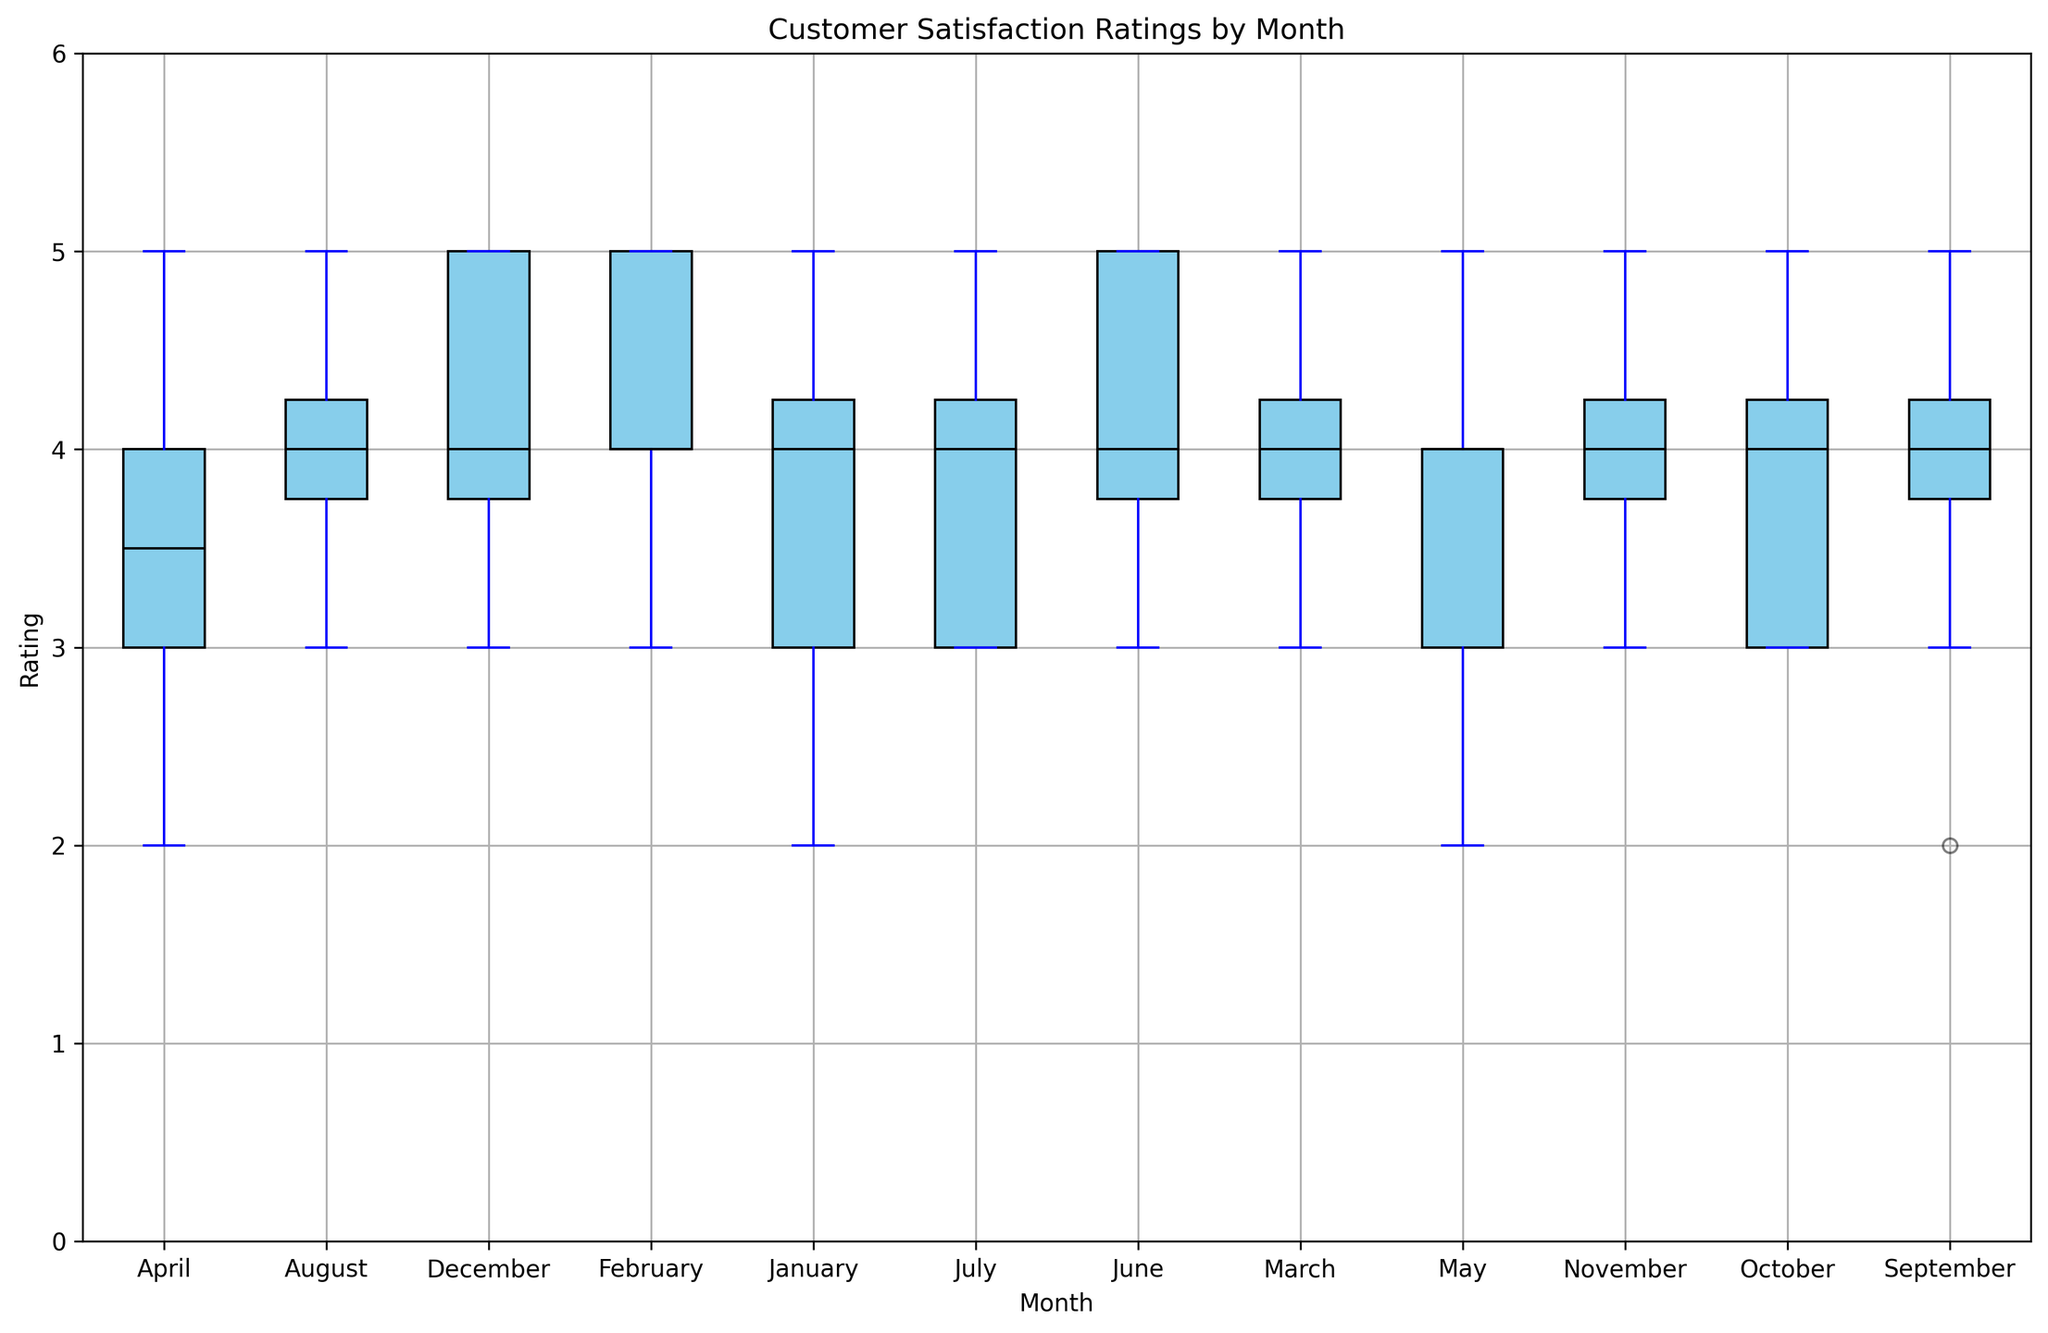Which month has the highest median customer satisfaction rating? Observe the median line in each box plot and identify the highest one. February, July, and December each have a median rating of 4.5, which is the highest observed.
Answer: February, July, and December Which month exhibits the largest range in customer satisfaction ratings? Look at the length of the whiskers (vertical lines) for each month to determine the range, which is the distance between the minimum and maximum points. The widest range is in January with ratings from 2 to 5.
Answer: January Which month has the least variability in customer satisfaction ratings? Variability can be judged by the interquartile range (IQR), which is the height of the box. March and May have the shortest boxes, suggesting the least variability.
Answer: March and May Is the median rating in April higher or lower than in October? Compare the median lines within the boxes for April and October. Both April and October have the same median rating of 4.
Answer: Equal During which months do we observe outliers in customer satisfaction ratings? Outliers are marked as individual red points outside the whiskers. Only January and September have outliers (ratings of 2 and 2 respectively).
Answer: January and September Which months have similar median ratings? Compare median lines across different months. Many months have a median of 4, including January, February, March, April, May, June, July, August, September, October, November, and December.
Answer: January, February, March, April, May, June, July, August, September, October, November, and December What is the median difference in customer satisfaction ratings between January and February? Observe the median line in January (which is 4) and compare it with February (which is 4.5). The difference is 4.5 - 4 = 0.5.
Answer: 0.5 In which month does the interquartile range (IQR) appear to be the greatest, and what does this indicate? Measure the height of the boxes. January exhibits one of the highest IQRs, indicating greater variability in customer satisfaction ratings compared to other months.
Answer: January Do the plots exhibit any months where the minimum rating is higher than other months' medians? Identify the minimum whisker of each month and compare it with the median lines of other months. For instance, February, where the minimum rating (3) is higher than or equal to the medians of other months like January, April, July, October, November, and December (4).
Answer: February How does the range of customer satisfaction ratings in the summer months (June to August) compare to the winter months (December to February)? Observe the lengths of the whiskers for June, July, August (summer) and December, January, February (winter). Both summer and winter months show similar variability, with the range approximately from 2/3 to 5.
Answer: Similar 